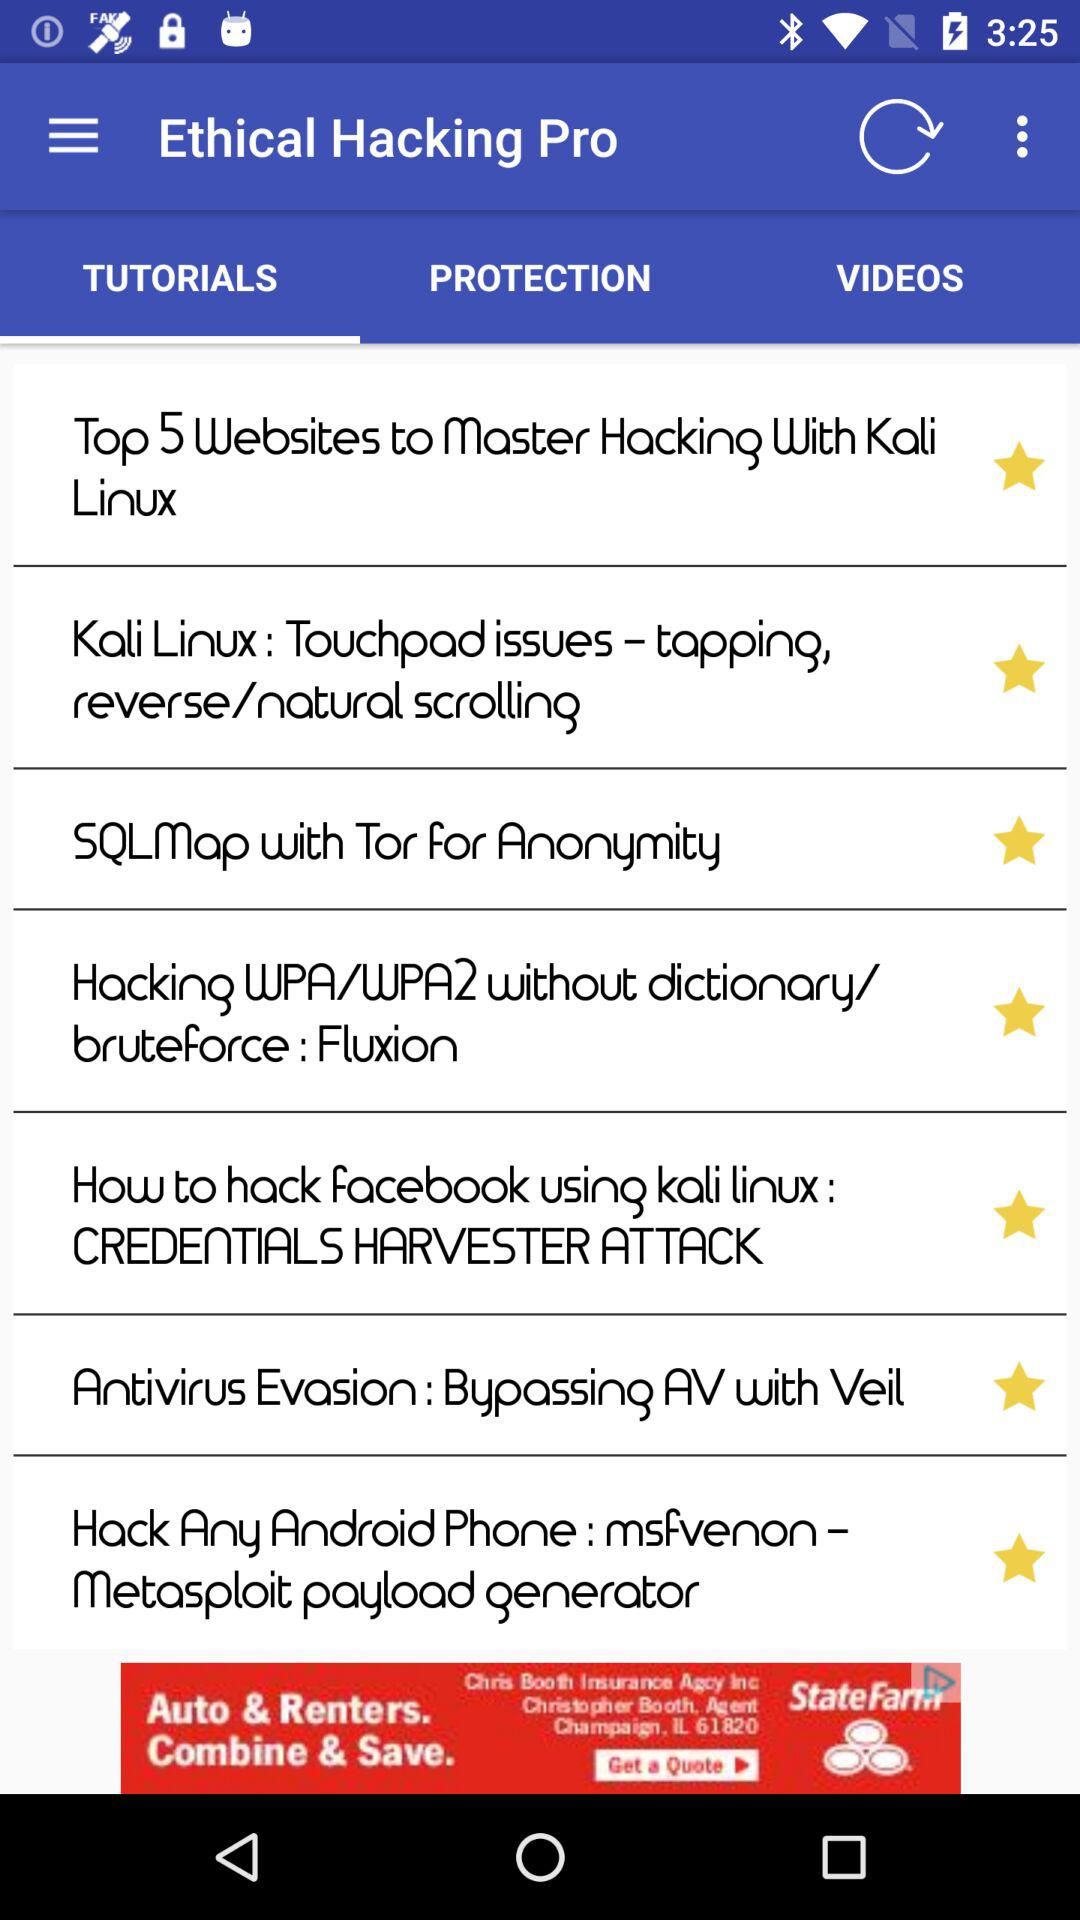How many languages are available to select?
Answer the question using a single word or phrase. 6 